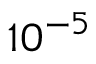Convert formula to latex. <formula><loc_0><loc_0><loc_500><loc_500>1 0 ^ { - 5 }</formula> 